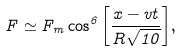<formula> <loc_0><loc_0><loc_500><loc_500>F \simeq F _ { m } \cos ^ { 6 } { \left [ \frac { x - v t } { R \sqrt { 1 0 } } \right ] } ,</formula> 